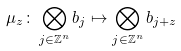Convert formula to latex. <formula><loc_0><loc_0><loc_500><loc_500>\mu _ { z } \colon \bigotimes _ { j \in \mathbb { Z } ^ { n } } b _ { j } \mapsto \bigotimes _ { j \in \mathbb { Z } ^ { n } } b _ { j + z }</formula> 